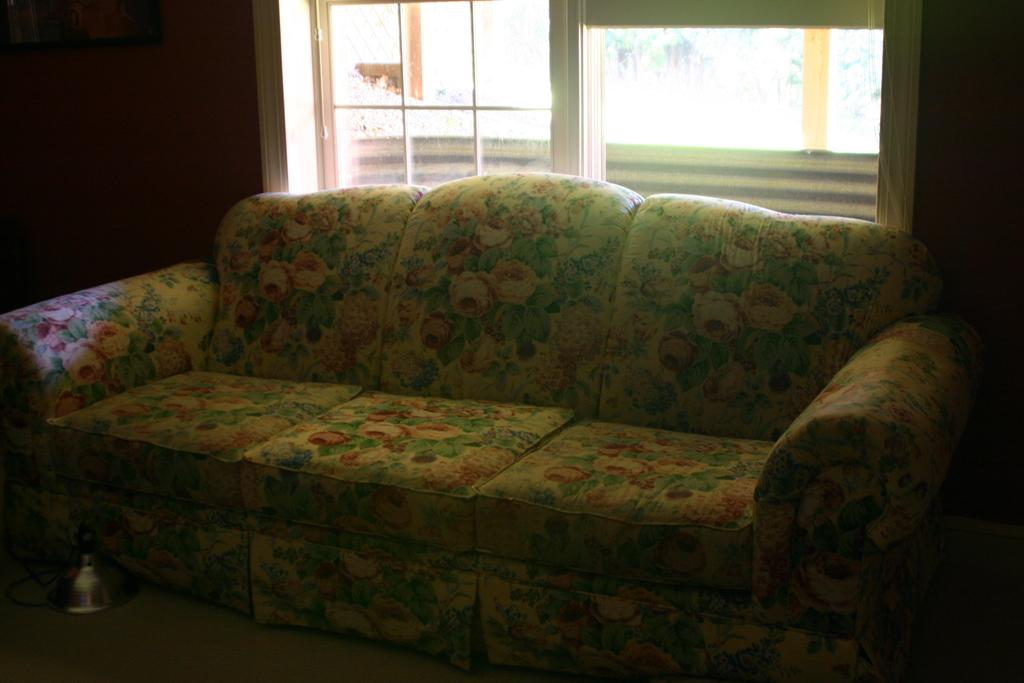What type of furniture is in the room? There is a sofa in the room. What design is on the back of the sofa? The sofa has a flower design on the back. Can you describe the window in the room? There is a window behind the sofa. What type of needle is being used to sew the sofa in the image? There is no needle present in the image, and the sofa is not being sewn. 